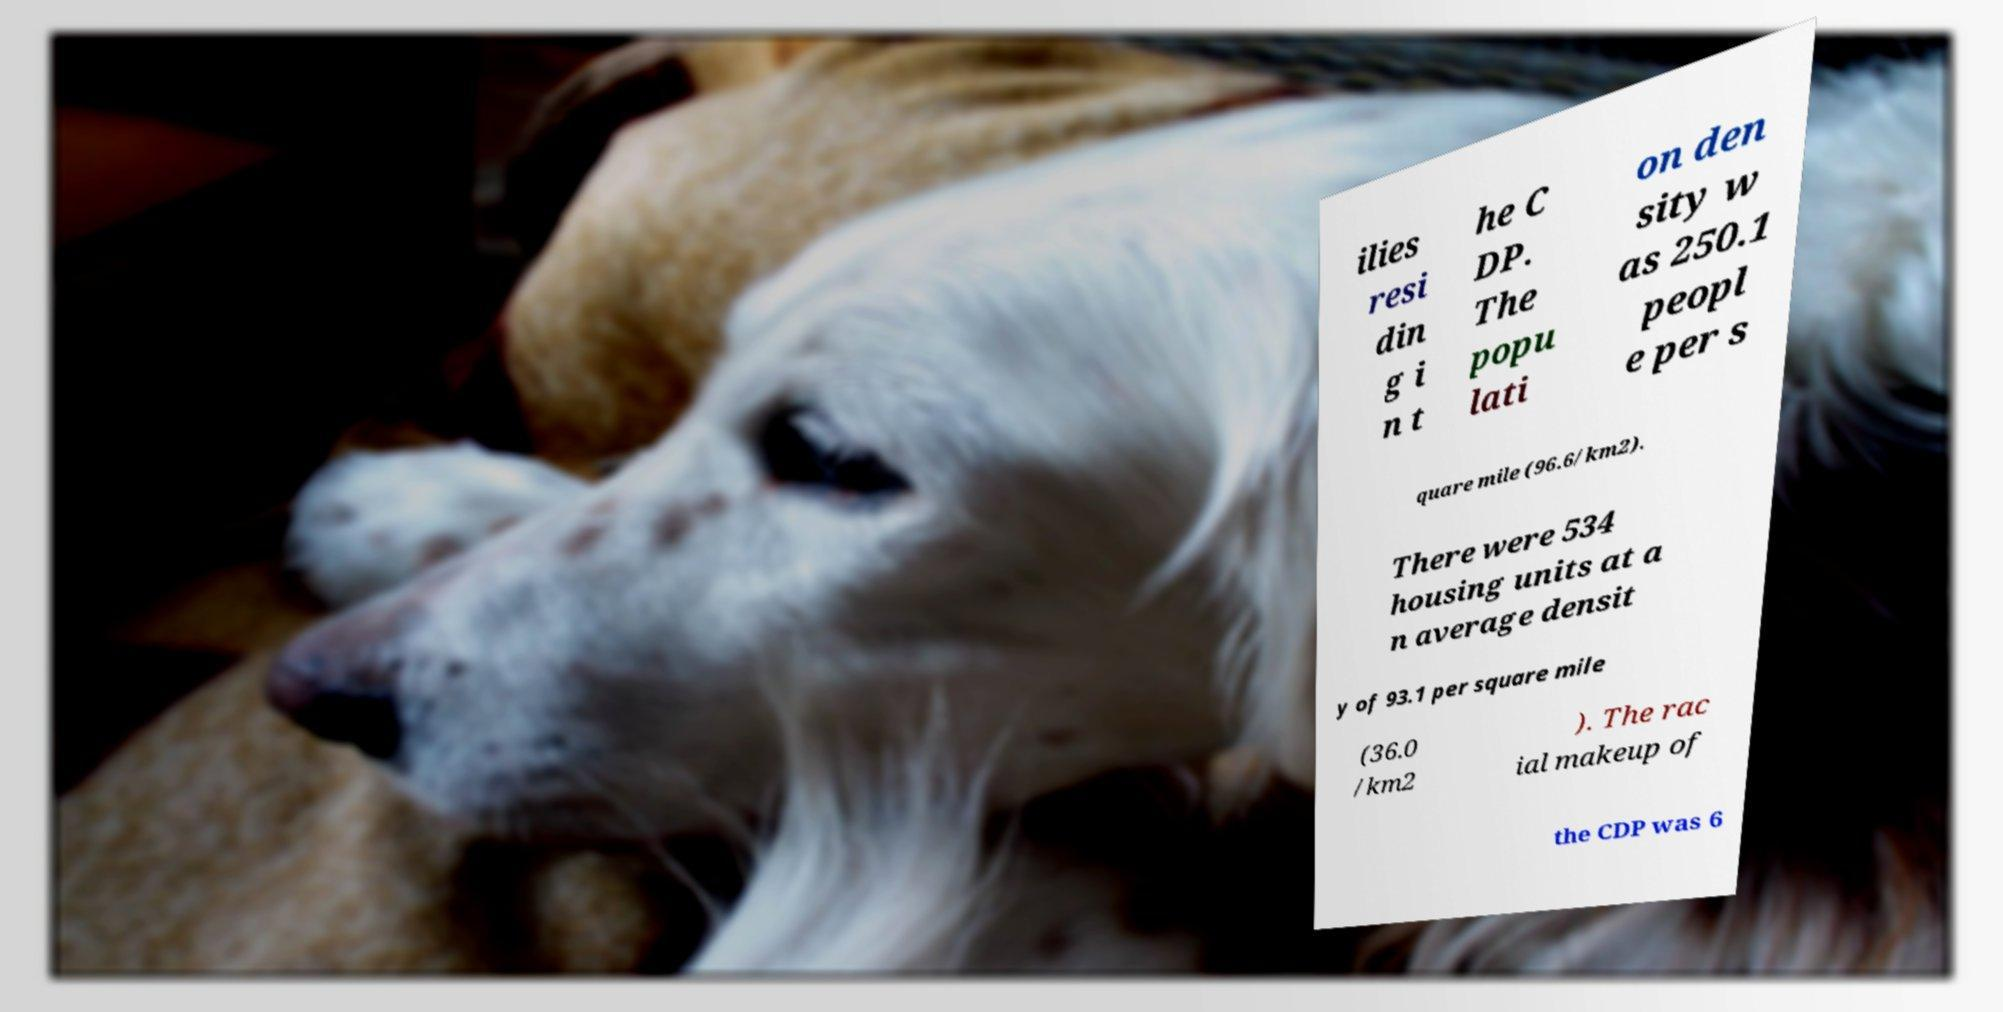Can you read and provide the text displayed in the image?This photo seems to have some interesting text. Can you extract and type it out for me? ilies resi din g i n t he C DP. The popu lati on den sity w as 250.1 peopl e per s quare mile (96.6/km2). There were 534 housing units at a n average densit y of 93.1 per square mile (36.0 /km2 ). The rac ial makeup of the CDP was 6 